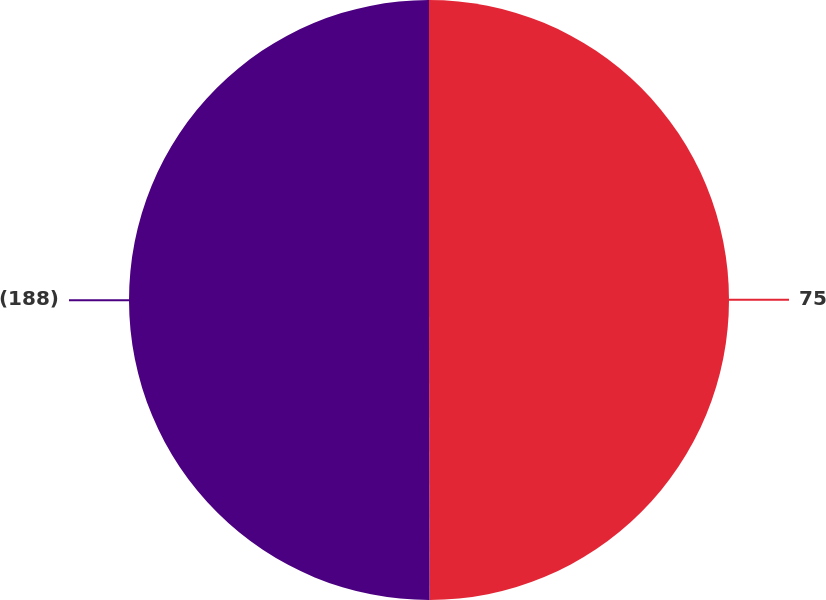<chart> <loc_0><loc_0><loc_500><loc_500><pie_chart><fcel>75<fcel>(188)<nl><fcel>49.97%<fcel>50.03%<nl></chart> 